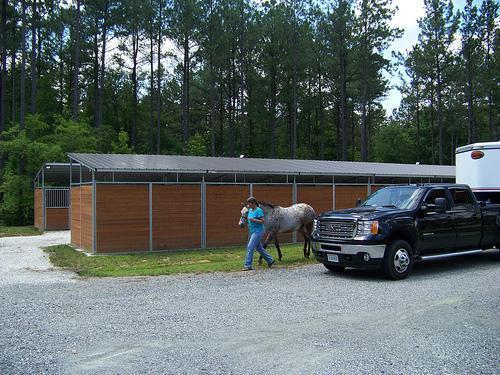How many horses can be seen?
Give a very brief answer. 1. 